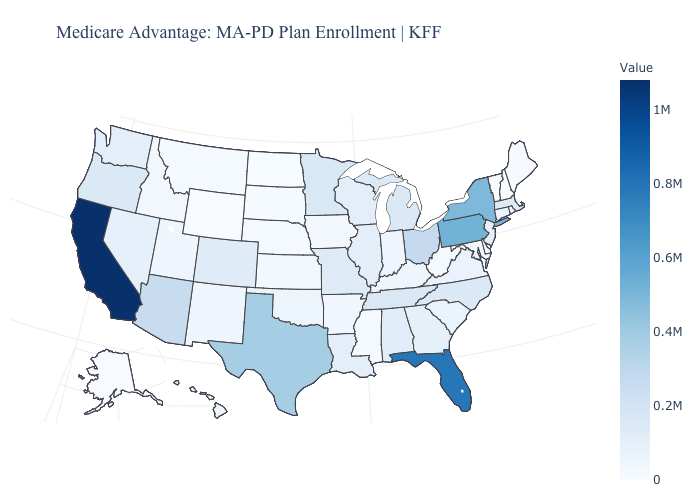Does North Dakota have a lower value than Texas?
Keep it brief. Yes. Which states have the highest value in the USA?
Concise answer only. California. Is the legend a continuous bar?
Concise answer only. Yes. Among the states that border Michigan , which have the highest value?
Concise answer only. Ohio. Which states hav the highest value in the South?
Give a very brief answer. Florida. Which states hav the highest value in the MidWest?
Keep it brief. Ohio. 